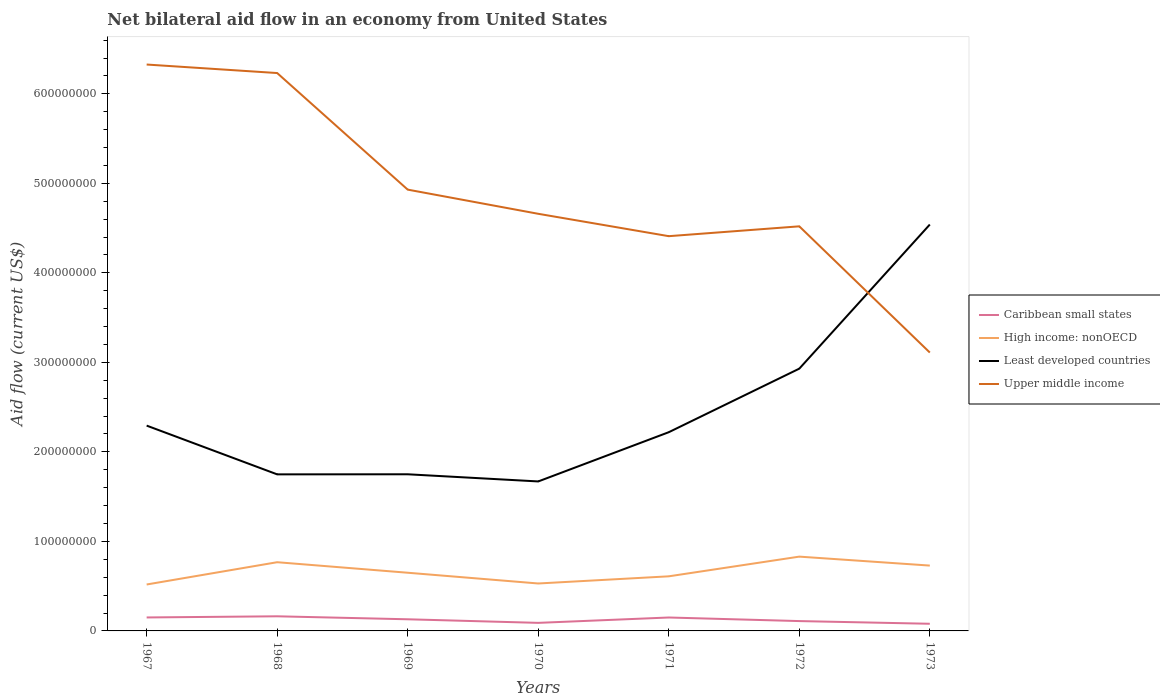Across all years, what is the maximum net bilateral aid flow in Caribbean small states?
Make the answer very short. 8.00e+06. In which year was the net bilateral aid flow in Least developed countries maximum?
Ensure brevity in your answer.  1970. What is the difference between the highest and the second highest net bilateral aid flow in High income: nonOECD?
Offer a very short reply. 3.11e+07. How many lines are there?
Ensure brevity in your answer.  4. What is the difference between two consecutive major ticks on the Y-axis?
Ensure brevity in your answer.  1.00e+08. Does the graph contain any zero values?
Provide a short and direct response. No. Does the graph contain grids?
Provide a succinct answer. No. How many legend labels are there?
Provide a succinct answer. 4. How are the legend labels stacked?
Offer a terse response. Vertical. What is the title of the graph?
Make the answer very short. Net bilateral aid flow in an economy from United States. Does "World" appear as one of the legend labels in the graph?
Offer a very short reply. No. What is the Aid flow (current US$) of Caribbean small states in 1967?
Give a very brief answer. 1.50e+07. What is the Aid flow (current US$) in High income: nonOECD in 1967?
Give a very brief answer. 5.19e+07. What is the Aid flow (current US$) in Least developed countries in 1967?
Ensure brevity in your answer.  2.29e+08. What is the Aid flow (current US$) in Upper middle income in 1967?
Provide a succinct answer. 6.33e+08. What is the Aid flow (current US$) in Caribbean small states in 1968?
Your answer should be compact. 1.63e+07. What is the Aid flow (current US$) in High income: nonOECD in 1968?
Make the answer very short. 7.68e+07. What is the Aid flow (current US$) of Least developed countries in 1968?
Give a very brief answer. 1.75e+08. What is the Aid flow (current US$) in Upper middle income in 1968?
Your answer should be compact. 6.23e+08. What is the Aid flow (current US$) in Caribbean small states in 1969?
Offer a terse response. 1.30e+07. What is the Aid flow (current US$) in High income: nonOECD in 1969?
Make the answer very short. 6.50e+07. What is the Aid flow (current US$) in Least developed countries in 1969?
Make the answer very short. 1.75e+08. What is the Aid flow (current US$) of Upper middle income in 1969?
Ensure brevity in your answer.  4.93e+08. What is the Aid flow (current US$) in Caribbean small states in 1970?
Provide a succinct answer. 9.00e+06. What is the Aid flow (current US$) in High income: nonOECD in 1970?
Your answer should be very brief. 5.30e+07. What is the Aid flow (current US$) of Least developed countries in 1970?
Your answer should be very brief. 1.67e+08. What is the Aid flow (current US$) in Upper middle income in 1970?
Your response must be concise. 4.66e+08. What is the Aid flow (current US$) in Caribbean small states in 1971?
Provide a short and direct response. 1.50e+07. What is the Aid flow (current US$) of High income: nonOECD in 1971?
Your answer should be very brief. 6.10e+07. What is the Aid flow (current US$) of Least developed countries in 1971?
Offer a terse response. 2.22e+08. What is the Aid flow (current US$) in Upper middle income in 1971?
Give a very brief answer. 4.41e+08. What is the Aid flow (current US$) in Caribbean small states in 1972?
Provide a short and direct response. 1.10e+07. What is the Aid flow (current US$) of High income: nonOECD in 1972?
Offer a terse response. 8.30e+07. What is the Aid flow (current US$) of Least developed countries in 1972?
Offer a terse response. 2.93e+08. What is the Aid flow (current US$) of Upper middle income in 1972?
Offer a terse response. 4.52e+08. What is the Aid flow (current US$) in Caribbean small states in 1973?
Offer a terse response. 8.00e+06. What is the Aid flow (current US$) in High income: nonOECD in 1973?
Offer a terse response. 7.30e+07. What is the Aid flow (current US$) in Least developed countries in 1973?
Your answer should be compact. 4.54e+08. What is the Aid flow (current US$) in Upper middle income in 1973?
Your answer should be very brief. 3.11e+08. Across all years, what is the maximum Aid flow (current US$) in Caribbean small states?
Give a very brief answer. 1.63e+07. Across all years, what is the maximum Aid flow (current US$) in High income: nonOECD?
Make the answer very short. 8.30e+07. Across all years, what is the maximum Aid flow (current US$) in Least developed countries?
Offer a very short reply. 4.54e+08. Across all years, what is the maximum Aid flow (current US$) of Upper middle income?
Offer a terse response. 6.33e+08. Across all years, what is the minimum Aid flow (current US$) in High income: nonOECD?
Your answer should be compact. 5.19e+07. Across all years, what is the minimum Aid flow (current US$) of Least developed countries?
Offer a very short reply. 1.67e+08. Across all years, what is the minimum Aid flow (current US$) of Upper middle income?
Give a very brief answer. 3.11e+08. What is the total Aid flow (current US$) in Caribbean small states in the graph?
Offer a very short reply. 8.74e+07. What is the total Aid flow (current US$) of High income: nonOECD in the graph?
Keep it short and to the point. 4.64e+08. What is the total Aid flow (current US$) in Least developed countries in the graph?
Keep it short and to the point. 1.72e+09. What is the total Aid flow (current US$) in Upper middle income in the graph?
Ensure brevity in your answer.  3.42e+09. What is the difference between the Aid flow (current US$) of Caribbean small states in 1967 and that in 1968?
Provide a succinct answer. -1.28e+06. What is the difference between the Aid flow (current US$) in High income: nonOECD in 1967 and that in 1968?
Offer a very short reply. -2.49e+07. What is the difference between the Aid flow (current US$) of Least developed countries in 1967 and that in 1968?
Your response must be concise. 5.45e+07. What is the difference between the Aid flow (current US$) in Upper middle income in 1967 and that in 1968?
Offer a terse response. 9.51e+06. What is the difference between the Aid flow (current US$) of Caribbean small states in 1967 and that in 1969?
Provide a succinct answer. 2.05e+06. What is the difference between the Aid flow (current US$) of High income: nonOECD in 1967 and that in 1969?
Make the answer very short. -1.31e+07. What is the difference between the Aid flow (current US$) of Least developed countries in 1967 and that in 1969?
Give a very brief answer. 5.44e+07. What is the difference between the Aid flow (current US$) of Upper middle income in 1967 and that in 1969?
Offer a terse response. 1.40e+08. What is the difference between the Aid flow (current US$) in Caribbean small states in 1967 and that in 1970?
Offer a terse response. 6.05e+06. What is the difference between the Aid flow (current US$) of High income: nonOECD in 1967 and that in 1970?
Keep it short and to the point. -1.13e+06. What is the difference between the Aid flow (current US$) of Least developed countries in 1967 and that in 1970?
Make the answer very short. 6.24e+07. What is the difference between the Aid flow (current US$) in Upper middle income in 1967 and that in 1970?
Keep it short and to the point. 1.67e+08. What is the difference between the Aid flow (current US$) in Caribbean small states in 1967 and that in 1971?
Offer a very short reply. 5.00e+04. What is the difference between the Aid flow (current US$) of High income: nonOECD in 1967 and that in 1971?
Offer a terse response. -9.13e+06. What is the difference between the Aid flow (current US$) of Least developed countries in 1967 and that in 1971?
Make the answer very short. 7.37e+06. What is the difference between the Aid flow (current US$) in Upper middle income in 1967 and that in 1971?
Your response must be concise. 1.92e+08. What is the difference between the Aid flow (current US$) in Caribbean small states in 1967 and that in 1972?
Ensure brevity in your answer.  4.05e+06. What is the difference between the Aid flow (current US$) in High income: nonOECD in 1967 and that in 1972?
Your answer should be very brief. -3.11e+07. What is the difference between the Aid flow (current US$) of Least developed countries in 1967 and that in 1972?
Your answer should be very brief. -6.36e+07. What is the difference between the Aid flow (current US$) in Upper middle income in 1967 and that in 1972?
Give a very brief answer. 1.81e+08. What is the difference between the Aid flow (current US$) of Caribbean small states in 1967 and that in 1973?
Make the answer very short. 7.05e+06. What is the difference between the Aid flow (current US$) in High income: nonOECD in 1967 and that in 1973?
Offer a terse response. -2.11e+07. What is the difference between the Aid flow (current US$) of Least developed countries in 1967 and that in 1973?
Offer a terse response. -2.25e+08. What is the difference between the Aid flow (current US$) of Upper middle income in 1967 and that in 1973?
Provide a succinct answer. 3.22e+08. What is the difference between the Aid flow (current US$) in Caribbean small states in 1968 and that in 1969?
Keep it short and to the point. 3.33e+06. What is the difference between the Aid flow (current US$) of High income: nonOECD in 1968 and that in 1969?
Keep it short and to the point. 1.18e+07. What is the difference between the Aid flow (current US$) of Least developed countries in 1968 and that in 1969?
Your response must be concise. -1.00e+05. What is the difference between the Aid flow (current US$) in Upper middle income in 1968 and that in 1969?
Your answer should be compact. 1.30e+08. What is the difference between the Aid flow (current US$) in Caribbean small states in 1968 and that in 1970?
Provide a succinct answer. 7.33e+06. What is the difference between the Aid flow (current US$) in High income: nonOECD in 1968 and that in 1970?
Keep it short and to the point. 2.38e+07. What is the difference between the Aid flow (current US$) of Least developed countries in 1968 and that in 1970?
Give a very brief answer. 7.90e+06. What is the difference between the Aid flow (current US$) of Upper middle income in 1968 and that in 1970?
Your answer should be very brief. 1.57e+08. What is the difference between the Aid flow (current US$) of Caribbean small states in 1968 and that in 1971?
Keep it short and to the point. 1.33e+06. What is the difference between the Aid flow (current US$) of High income: nonOECD in 1968 and that in 1971?
Your answer should be very brief. 1.58e+07. What is the difference between the Aid flow (current US$) of Least developed countries in 1968 and that in 1971?
Offer a terse response. -4.71e+07. What is the difference between the Aid flow (current US$) of Upper middle income in 1968 and that in 1971?
Ensure brevity in your answer.  1.82e+08. What is the difference between the Aid flow (current US$) of Caribbean small states in 1968 and that in 1972?
Provide a succinct answer. 5.33e+06. What is the difference between the Aid flow (current US$) of High income: nonOECD in 1968 and that in 1972?
Your answer should be very brief. -6.24e+06. What is the difference between the Aid flow (current US$) of Least developed countries in 1968 and that in 1972?
Your answer should be very brief. -1.18e+08. What is the difference between the Aid flow (current US$) in Upper middle income in 1968 and that in 1972?
Your answer should be very brief. 1.71e+08. What is the difference between the Aid flow (current US$) of Caribbean small states in 1968 and that in 1973?
Your answer should be compact. 8.33e+06. What is the difference between the Aid flow (current US$) of High income: nonOECD in 1968 and that in 1973?
Offer a terse response. 3.76e+06. What is the difference between the Aid flow (current US$) in Least developed countries in 1968 and that in 1973?
Keep it short and to the point. -2.79e+08. What is the difference between the Aid flow (current US$) of Upper middle income in 1968 and that in 1973?
Offer a terse response. 3.12e+08. What is the difference between the Aid flow (current US$) of Caribbean small states in 1969 and that in 1970?
Your answer should be compact. 4.00e+06. What is the difference between the Aid flow (current US$) in High income: nonOECD in 1969 and that in 1970?
Your response must be concise. 1.20e+07. What is the difference between the Aid flow (current US$) in Least developed countries in 1969 and that in 1970?
Offer a terse response. 8.00e+06. What is the difference between the Aid flow (current US$) of Upper middle income in 1969 and that in 1970?
Your answer should be very brief. 2.70e+07. What is the difference between the Aid flow (current US$) of Least developed countries in 1969 and that in 1971?
Ensure brevity in your answer.  -4.70e+07. What is the difference between the Aid flow (current US$) in Upper middle income in 1969 and that in 1971?
Ensure brevity in your answer.  5.20e+07. What is the difference between the Aid flow (current US$) in High income: nonOECD in 1969 and that in 1972?
Your answer should be very brief. -1.80e+07. What is the difference between the Aid flow (current US$) in Least developed countries in 1969 and that in 1972?
Make the answer very short. -1.18e+08. What is the difference between the Aid flow (current US$) in Upper middle income in 1969 and that in 1972?
Provide a short and direct response. 4.10e+07. What is the difference between the Aid flow (current US$) in High income: nonOECD in 1969 and that in 1973?
Provide a short and direct response. -8.00e+06. What is the difference between the Aid flow (current US$) of Least developed countries in 1969 and that in 1973?
Ensure brevity in your answer.  -2.79e+08. What is the difference between the Aid flow (current US$) in Upper middle income in 1969 and that in 1973?
Offer a terse response. 1.82e+08. What is the difference between the Aid flow (current US$) of Caribbean small states in 1970 and that in 1971?
Your answer should be very brief. -6.00e+06. What is the difference between the Aid flow (current US$) in High income: nonOECD in 1970 and that in 1971?
Your answer should be compact. -8.00e+06. What is the difference between the Aid flow (current US$) in Least developed countries in 1970 and that in 1971?
Your response must be concise. -5.50e+07. What is the difference between the Aid flow (current US$) of Upper middle income in 1970 and that in 1971?
Your answer should be very brief. 2.50e+07. What is the difference between the Aid flow (current US$) of Caribbean small states in 1970 and that in 1972?
Give a very brief answer. -2.00e+06. What is the difference between the Aid flow (current US$) in High income: nonOECD in 1970 and that in 1972?
Your answer should be compact. -3.00e+07. What is the difference between the Aid flow (current US$) in Least developed countries in 1970 and that in 1972?
Provide a short and direct response. -1.26e+08. What is the difference between the Aid flow (current US$) of Upper middle income in 1970 and that in 1972?
Your answer should be very brief. 1.40e+07. What is the difference between the Aid flow (current US$) in High income: nonOECD in 1970 and that in 1973?
Offer a very short reply. -2.00e+07. What is the difference between the Aid flow (current US$) of Least developed countries in 1970 and that in 1973?
Your answer should be compact. -2.87e+08. What is the difference between the Aid flow (current US$) in Upper middle income in 1970 and that in 1973?
Provide a short and direct response. 1.55e+08. What is the difference between the Aid flow (current US$) in High income: nonOECD in 1971 and that in 1972?
Keep it short and to the point. -2.20e+07. What is the difference between the Aid flow (current US$) of Least developed countries in 1971 and that in 1972?
Your response must be concise. -7.10e+07. What is the difference between the Aid flow (current US$) in Upper middle income in 1971 and that in 1972?
Your response must be concise. -1.10e+07. What is the difference between the Aid flow (current US$) in High income: nonOECD in 1971 and that in 1973?
Your response must be concise. -1.20e+07. What is the difference between the Aid flow (current US$) in Least developed countries in 1971 and that in 1973?
Give a very brief answer. -2.32e+08. What is the difference between the Aid flow (current US$) in Upper middle income in 1971 and that in 1973?
Offer a terse response. 1.30e+08. What is the difference between the Aid flow (current US$) of High income: nonOECD in 1972 and that in 1973?
Your response must be concise. 1.00e+07. What is the difference between the Aid flow (current US$) of Least developed countries in 1972 and that in 1973?
Offer a very short reply. -1.61e+08. What is the difference between the Aid flow (current US$) in Upper middle income in 1972 and that in 1973?
Provide a succinct answer. 1.41e+08. What is the difference between the Aid flow (current US$) in Caribbean small states in 1967 and the Aid flow (current US$) in High income: nonOECD in 1968?
Ensure brevity in your answer.  -6.17e+07. What is the difference between the Aid flow (current US$) in Caribbean small states in 1967 and the Aid flow (current US$) in Least developed countries in 1968?
Provide a succinct answer. -1.60e+08. What is the difference between the Aid flow (current US$) of Caribbean small states in 1967 and the Aid flow (current US$) of Upper middle income in 1968?
Provide a succinct answer. -6.08e+08. What is the difference between the Aid flow (current US$) in High income: nonOECD in 1967 and the Aid flow (current US$) in Least developed countries in 1968?
Offer a terse response. -1.23e+08. What is the difference between the Aid flow (current US$) of High income: nonOECD in 1967 and the Aid flow (current US$) of Upper middle income in 1968?
Ensure brevity in your answer.  -5.71e+08. What is the difference between the Aid flow (current US$) in Least developed countries in 1967 and the Aid flow (current US$) in Upper middle income in 1968?
Your response must be concise. -3.94e+08. What is the difference between the Aid flow (current US$) in Caribbean small states in 1967 and the Aid flow (current US$) in High income: nonOECD in 1969?
Offer a very short reply. -5.00e+07. What is the difference between the Aid flow (current US$) of Caribbean small states in 1967 and the Aid flow (current US$) of Least developed countries in 1969?
Give a very brief answer. -1.60e+08. What is the difference between the Aid flow (current US$) in Caribbean small states in 1967 and the Aid flow (current US$) in Upper middle income in 1969?
Your answer should be very brief. -4.78e+08. What is the difference between the Aid flow (current US$) of High income: nonOECD in 1967 and the Aid flow (current US$) of Least developed countries in 1969?
Offer a terse response. -1.23e+08. What is the difference between the Aid flow (current US$) of High income: nonOECD in 1967 and the Aid flow (current US$) of Upper middle income in 1969?
Offer a terse response. -4.41e+08. What is the difference between the Aid flow (current US$) of Least developed countries in 1967 and the Aid flow (current US$) of Upper middle income in 1969?
Ensure brevity in your answer.  -2.64e+08. What is the difference between the Aid flow (current US$) in Caribbean small states in 1967 and the Aid flow (current US$) in High income: nonOECD in 1970?
Provide a short and direct response. -3.80e+07. What is the difference between the Aid flow (current US$) in Caribbean small states in 1967 and the Aid flow (current US$) in Least developed countries in 1970?
Make the answer very short. -1.52e+08. What is the difference between the Aid flow (current US$) in Caribbean small states in 1967 and the Aid flow (current US$) in Upper middle income in 1970?
Your answer should be compact. -4.51e+08. What is the difference between the Aid flow (current US$) in High income: nonOECD in 1967 and the Aid flow (current US$) in Least developed countries in 1970?
Offer a terse response. -1.15e+08. What is the difference between the Aid flow (current US$) in High income: nonOECD in 1967 and the Aid flow (current US$) in Upper middle income in 1970?
Your answer should be compact. -4.14e+08. What is the difference between the Aid flow (current US$) of Least developed countries in 1967 and the Aid flow (current US$) of Upper middle income in 1970?
Keep it short and to the point. -2.37e+08. What is the difference between the Aid flow (current US$) in Caribbean small states in 1967 and the Aid flow (current US$) in High income: nonOECD in 1971?
Provide a short and direct response. -4.60e+07. What is the difference between the Aid flow (current US$) in Caribbean small states in 1967 and the Aid flow (current US$) in Least developed countries in 1971?
Provide a short and direct response. -2.07e+08. What is the difference between the Aid flow (current US$) in Caribbean small states in 1967 and the Aid flow (current US$) in Upper middle income in 1971?
Offer a very short reply. -4.26e+08. What is the difference between the Aid flow (current US$) in High income: nonOECD in 1967 and the Aid flow (current US$) in Least developed countries in 1971?
Your answer should be very brief. -1.70e+08. What is the difference between the Aid flow (current US$) of High income: nonOECD in 1967 and the Aid flow (current US$) of Upper middle income in 1971?
Provide a short and direct response. -3.89e+08. What is the difference between the Aid flow (current US$) of Least developed countries in 1967 and the Aid flow (current US$) of Upper middle income in 1971?
Your answer should be compact. -2.12e+08. What is the difference between the Aid flow (current US$) in Caribbean small states in 1967 and the Aid flow (current US$) in High income: nonOECD in 1972?
Your answer should be compact. -6.80e+07. What is the difference between the Aid flow (current US$) in Caribbean small states in 1967 and the Aid flow (current US$) in Least developed countries in 1972?
Provide a short and direct response. -2.78e+08. What is the difference between the Aid flow (current US$) in Caribbean small states in 1967 and the Aid flow (current US$) in Upper middle income in 1972?
Give a very brief answer. -4.37e+08. What is the difference between the Aid flow (current US$) of High income: nonOECD in 1967 and the Aid flow (current US$) of Least developed countries in 1972?
Your response must be concise. -2.41e+08. What is the difference between the Aid flow (current US$) in High income: nonOECD in 1967 and the Aid flow (current US$) in Upper middle income in 1972?
Your response must be concise. -4.00e+08. What is the difference between the Aid flow (current US$) in Least developed countries in 1967 and the Aid flow (current US$) in Upper middle income in 1972?
Your answer should be compact. -2.23e+08. What is the difference between the Aid flow (current US$) of Caribbean small states in 1967 and the Aid flow (current US$) of High income: nonOECD in 1973?
Give a very brief answer. -5.80e+07. What is the difference between the Aid flow (current US$) of Caribbean small states in 1967 and the Aid flow (current US$) of Least developed countries in 1973?
Offer a very short reply. -4.39e+08. What is the difference between the Aid flow (current US$) of Caribbean small states in 1967 and the Aid flow (current US$) of Upper middle income in 1973?
Make the answer very short. -2.96e+08. What is the difference between the Aid flow (current US$) of High income: nonOECD in 1967 and the Aid flow (current US$) of Least developed countries in 1973?
Provide a short and direct response. -4.02e+08. What is the difference between the Aid flow (current US$) of High income: nonOECD in 1967 and the Aid flow (current US$) of Upper middle income in 1973?
Offer a terse response. -2.59e+08. What is the difference between the Aid flow (current US$) in Least developed countries in 1967 and the Aid flow (current US$) in Upper middle income in 1973?
Give a very brief answer. -8.16e+07. What is the difference between the Aid flow (current US$) of Caribbean small states in 1968 and the Aid flow (current US$) of High income: nonOECD in 1969?
Keep it short and to the point. -4.87e+07. What is the difference between the Aid flow (current US$) of Caribbean small states in 1968 and the Aid flow (current US$) of Least developed countries in 1969?
Offer a very short reply. -1.59e+08. What is the difference between the Aid flow (current US$) in Caribbean small states in 1968 and the Aid flow (current US$) in Upper middle income in 1969?
Ensure brevity in your answer.  -4.77e+08. What is the difference between the Aid flow (current US$) in High income: nonOECD in 1968 and the Aid flow (current US$) in Least developed countries in 1969?
Keep it short and to the point. -9.82e+07. What is the difference between the Aid flow (current US$) of High income: nonOECD in 1968 and the Aid flow (current US$) of Upper middle income in 1969?
Provide a succinct answer. -4.16e+08. What is the difference between the Aid flow (current US$) in Least developed countries in 1968 and the Aid flow (current US$) in Upper middle income in 1969?
Offer a very short reply. -3.18e+08. What is the difference between the Aid flow (current US$) in Caribbean small states in 1968 and the Aid flow (current US$) in High income: nonOECD in 1970?
Your answer should be compact. -3.67e+07. What is the difference between the Aid flow (current US$) of Caribbean small states in 1968 and the Aid flow (current US$) of Least developed countries in 1970?
Make the answer very short. -1.51e+08. What is the difference between the Aid flow (current US$) in Caribbean small states in 1968 and the Aid flow (current US$) in Upper middle income in 1970?
Give a very brief answer. -4.50e+08. What is the difference between the Aid flow (current US$) of High income: nonOECD in 1968 and the Aid flow (current US$) of Least developed countries in 1970?
Provide a short and direct response. -9.02e+07. What is the difference between the Aid flow (current US$) in High income: nonOECD in 1968 and the Aid flow (current US$) in Upper middle income in 1970?
Provide a succinct answer. -3.89e+08. What is the difference between the Aid flow (current US$) of Least developed countries in 1968 and the Aid flow (current US$) of Upper middle income in 1970?
Keep it short and to the point. -2.91e+08. What is the difference between the Aid flow (current US$) in Caribbean small states in 1968 and the Aid flow (current US$) in High income: nonOECD in 1971?
Make the answer very short. -4.47e+07. What is the difference between the Aid flow (current US$) of Caribbean small states in 1968 and the Aid flow (current US$) of Least developed countries in 1971?
Ensure brevity in your answer.  -2.06e+08. What is the difference between the Aid flow (current US$) in Caribbean small states in 1968 and the Aid flow (current US$) in Upper middle income in 1971?
Your answer should be compact. -4.25e+08. What is the difference between the Aid flow (current US$) in High income: nonOECD in 1968 and the Aid flow (current US$) in Least developed countries in 1971?
Your answer should be compact. -1.45e+08. What is the difference between the Aid flow (current US$) of High income: nonOECD in 1968 and the Aid flow (current US$) of Upper middle income in 1971?
Make the answer very short. -3.64e+08. What is the difference between the Aid flow (current US$) in Least developed countries in 1968 and the Aid flow (current US$) in Upper middle income in 1971?
Provide a succinct answer. -2.66e+08. What is the difference between the Aid flow (current US$) in Caribbean small states in 1968 and the Aid flow (current US$) in High income: nonOECD in 1972?
Provide a succinct answer. -6.67e+07. What is the difference between the Aid flow (current US$) in Caribbean small states in 1968 and the Aid flow (current US$) in Least developed countries in 1972?
Your answer should be compact. -2.77e+08. What is the difference between the Aid flow (current US$) of Caribbean small states in 1968 and the Aid flow (current US$) of Upper middle income in 1972?
Provide a short and direct response. -4.36e+08. What is the difference between the Aid flow (current US$) in High income: nonOECD in 1968 and the Aid flow (current US$) in Least developed countries in 1972?
Your answer should be very brief. -2.16e+08. What is the difference between the Aid flow (current US$) in High income: nonOECD in 1968 and the Aid flow (current US$) in Upper middle income in 1972?
Offer a very short reply. -3.75e+08. What is the difference between the Aid flow (current US$) of Least developed countries in 1968 and the Aid flow (current US$) of Upper middle income in 1972?
Make the answer very short. -2.77e+08. What is the difference between the Aid flow (current US$) of Caribbean small states in 1968 and the Aid flow (current US$) of High income: nonOECD in 1973?
Provide a succinct answer. -5.67e+07. What is the difference between the Aid flow (current US$) of Caribbean small states in 1968 and the Aid flow (current US$) of Least developed countries in 1973?
Give a very brief answer. -4.38e+08. What is the difference between the Aid flow (current US$) of Caribbean small states in 1968 and the Aid flow (current US$) of Upper middle income in 1973?
Provide a succinct answer. -2.95e+08. What is the difference between the Aid flow (current US$) of High income: nonOECD in 1968 and the Aid flow (current US$) of Least developed countries in 1973?
Offer a very short reply. -3.77e+08. What is the difference between the Aid flow (current US$) of High income: nonOECD in 1968 and the Aid flow (current US$) of Upper middle income in 1973?
Keep it short and to the point. -2.34e+08. What is the difference between the Aid flow (current US$) in Least developed countries in 1968 and the Aid flow (current US$) in Upper middle income in 1973?
Your answer should be compact. -1.36e+08. What is the difference between the Aid flow (current US$) in Caribbean small states in 1969 and the Aid flow (current US$) in High income: nonOECD in 1970?
Make the answer very short. -4.00e+07. What is the difference between the Aid flow (current US$) of Caribbean small states in 1969 and the Aid flow (current US$) of Least developed countries in 1970?
Your answer should be very brief. -1.54e+08. What is the difference between the Aid flow (current US$) of Caribbean small states in 1969 and the Aid flow (current US$) of Upper middle income in 1970?
Make the answer very short. -4.53e+08. What is the difference between the Aid flow (current US$) of High income: nonOECD in 1969 and the Aid flow (current US$) of Least developed countries in 1970?
Keep it short and to the point. -1.02e+08. What is the difference between the Aid flow (current US$) of High income: nonOECD in 1969 and the Aid flow (current US$) of Upper middle income in 1970?
Your answer should be compact. -4.01e+08. What is the difference between the Aid flow (current US$) of Least developed countries in 1969 and the Aid flow (current US$) of Upper middle income in 1970?
Offer a very short reply. -2.91e+08. What is the difference between the Aid flow (current US$) of Caribbean small states in 1969 and the Aid flow (current US$) of High income: nonOECD in 1971?
Make the answer very short. -4.80e+07. What is the difference between the Aid flow (current US$) in Caribbean small states in 1969 and the Aid flow (current US$) in Least developed countries in 1971?
Provide a short and direct response. -2.09e+08. What is the difference between the Aid flow (current US$) of Caribbean small states in 1969 and the Aid flow (current US$) of Upper middle income in 1971?
Provide a succinct answer. -4.28e+08. What is the difference between the Aid flow (current US$) of High income: nonOECD in 1969 and the Aid flow (current US$) of Least developed countries in 1971?
Ensure brevity in your answer.  -1.57e+08. What is the difference between the Aid flow (current US$) in High income: nonOECD in 1969 and the Aid flow (current US$) in Upper middle income in 1971?
Offer a terse response. -3.76e+08. What is the difference between the Aid flow (current US$) of Least developed countries in 1969 and the Aid flow (current US$) of Upper middle income in 1971?
Your answer should be very brief. -2.66e+08. What is the difference between the Aid flow (current US$) of Caribbean small states in 1969 and the Aid flow (current US$) of High income: nonOECD in 1972?
Ensure brevity in your answer.  -7.00e+07. What is the difference between the Aid flow (current US$) in Caribbean small states in 1969 and the Aid flow (current US$) in Least developed countries in 1972?
Keep it short and to the point. -2.80e+08. What is the difference between the Aid flow (current US$) in Caribbean small states in 1969 and the Aid flow (current US$) in Upper middle income in 1972?
Offer a very short reply. -4.39e+08. What is the difference between the Aid flow (current US$) in High income: nonOECD in 1969 and the Aid flow (current US$) in Least developed countries in 1972?
Give a very brief answer. -2.28e+08. What is the difference between the Aid flow (current US$) in High income: nonOECD in 1969 and the Aid flow (current US$) in Upper middle income in 1972?
Your response must be concise. -3.87e+08. What is the difference between the Aid flow (current US$) in Least developed countries in 1969 and the Aid flow (current US$) in Upper middle income in 1972?
Ensure brevity in your answer.  -2.77e+08. What is the difference between the Aid flow (current US$) of Caribbean small states in 1969 and the Aid flow (current US$) of High income: nonOECD in 1973?
Your response must be concise. -6.00e+07. What is the difference between the Aid flow (current US$) in Caribbean small states in 1969 and the Aid flow (current US$) in Least developed countries in 1973?
Provide a succinct answer. -4.41e+08. What is the difference between the Aid flow (current US$) in Caribbean small states in 1969 and the Aid flow (current US$) in Upper middle income in 1973?
Make the answer very short. -2.98e+08. What is the difference between the Aid flow (current US$) of High income: nonOECD in 1969 and the Aid flow (current US$) of Least developed countries in 1973?
Provide a succinct answer. -3.89e+08. What is the difference between the Aid flow (current US$) in High income: nonOECD in 1969 and the Aid flow (current US$) in Upper middle income in 1973?
Give a very brief answer. -2.46e+08. What is the difference between the Aid flow (current US$) of Least developed countries in 1969 and the Aid flow (current US$) of Upper middle income in 1973?
Your answer should be very brief. -1.36e+08. What is the difference between the Aid flow (current US$) in Caribbean small states in 1970 and the Aid flow (current US$) in High income: nonOECD in 1971?
Your answer should be very brief. -5.20e+07. What is the difference between the Aid flow (current US$) of Caribbean small states in 1970 and the Aid flow (current US$) of Least developed countries in 1971?
Keep it short and to the point. -2.13e+08. What is the difference between the Aid flow (current US$) of Caribbean small states in 1970 and the Aid flow (current US$) of Upper middle income in 1971?
Your response must be concise. -4.32e+08. What is the difference between the Aid flow (current US$) of High income: nonOECD in 1970 and the Aid flow (current US$) of Least developed countries in 1971?
Ensure brevity in your answer.  -1.69e+08. What is the difference between the Aid flow (current US$) of High income: nonOECD in 1970 and the Aid flow (current US$) of Upper middle income in 1971?
Your answer should be compact. -3.88e+08. What is the difference between the Aid flow (current US$) of Least developed countries in 1970 and the Aid flow (current US$) of Upper middle income in 1971?
Your response must be concise. -2.74e+08. What is the difference between the Aid flow (current US$) of Caribbean small states in 1970 and the Aid flow (current US$) of High income: nonOECD in 1972?
Your response must be concise. -7.40e+07. What is the difference between the Aid flow (current US$) of Caribbean small states in 1970 and the Aid flow (current US$) of Least developed countries in 1972?
Your answer should be very brief. -2.84e+08. What is the difference between the Aid flow (current US$) in Caribbean small states in 1970 and the Aid flow (current US$) in Upper middle income in 1972?
Provide a short and direct response. -4.43e+08. What is the difference between the Aid flow (current US$) of High income: nonOECD in 1970 and the Aid flow (current US$) of Least developed countries in 1972?
Your answer should be very brief. -2.40e+08. What is the difference between the Aid flow (current US$) of High income: nonOECD in 1970 and the Aid flow (current US$) of Upper middle income in 1972?
Give a very brief answer. -3.99e+08. What is the difference between the Aid flow (current US$) in Least developed countries in 1970 and the Aid flow (current US$) in Upper middle income in 1972?
Keep it short and to the point. -2.85e+08. What is the difference between the Aid flow (current US$) of Caribbean small states in 1970 and the Aid flow (current US$) of High income: nonOECD in 1973?
Your answer should be compact. -6.40e+07. What is the difference between the Aid flow (current US$) in Caribbean small states in 1970 and the Aid flow (current US$) in Least developed countries in 1973?
Provide a succinct answer. -4.45e+08. What is the difference between the Aid flow (current US$) in Caribbean small states in 1970 and the Aid flow (current US$) in Upper middle income in 1973?
Give a very brief answer. -3.02e+08. What is the difference between the Aid flow (current US$) in High income: nonOECD in 1970 and the Aid flow (current US$) in Least developed countries in 1973?
Your response must be concise. -4.01e+08. What is the difference between the Aid flow (current US$) of High income: nonOECD in 1970 and the Aid flow (current US$) of Upper middle income in 1973?
Give a very brief answer. -2.58e+08. What is the difference between the Aid flow (current US$) of Least developed countries in 1970 and the Aid flow (current US$) of Upper middle income in 1973?
Ensure brevity in your answer.  -1.44e+08. What is the difference between the Aid flow (current US$) of Caribbean small states in 1971 and the Aid flow (current US$) of High income: nonOECD in 1972?
Make the answer very short. -6.80e+07. What is the difference between the Aid flow (current US$) of Caribbean small states in 1971 and the Aid flow (current US$) of Least developed countries in 1972?
Offer a very short reply. -2.78e+08. What is the difference between the Aid flow (current US$) in Caribbean small states in 1971 and the Aid flow (current US$) in Upper middle income in 1972?
Your response must be concise. -4.37e+08. What is the difference between the Aid flow (current US$) of High income: nonOECD in 1971 and the Aid flow (current US$) of Least developed countries in 1972?
Offer a terse response. -2.32e+08. What is the difference between the Aid flow (current US$) of High income: nonOECD in 1971 and the Aid flow (current US$) of Upper middle income in 1972?
Give a very brief answer. -3.91e+08. What is the difference between the Aid flow (current US$) in Least developed countries in 1971 and the Aid flow (current US$) in Upper middle income in 1972?
Make the answer very short. -2.30e+08. What is the difference between the Aid flow (current US$) in Caribbean small states in 1971 and the Aid flow (current US$) in High income: nonOECD in 1973?
Provide a short and direct response. -5.80e+07. What is the difference between the Aid flow (current US$) in Caribbean small states in 1971 and the Aid flow (current US$) in Least developed countries in 1973?
Ensure brevity in your answer.  -4.39e+08. What is the difference between the Aid flow (current US$) in Caribbean small states in 1971 and the Aid flow (current US$) in Upper middle income in 1973?
Your answer should be very brief. -2.96e+08. What is the difference between the Aid flow (current US$) in High income: nonOECD in 1971 and the Aid flow (current US$) in Least developed countries in 1973?
Ensure brevity in your answer.  -3.93e+08. What is the difference between the Aid flow (current US$) in High income: nonOECD in 1971 and the Aid flow (current US$) in Upper middle income in 1973?
Your answer should be compact. -2.50e+08. What is the difference between the Aid flow (current US$) of Least developed countries in 1971 and the Aid flow (current US$) of Upper middle income in 1973?
Ensure brevity in your answer.  -8.90e+07. What is the difference between the Aid flow (current US$) in Caribbean small states in 1972 and the Aid flow (current US$) in High income: nonOECD in 1973?
Provide a short and direct response. -6.20e+07. What is the difference between the Aid flow (current US$) in Caribbean small states in 1972 and the Aid flow (current US$) in Least developed countries in 1973?
Provide a short and direct response. -4.43e+08. What is the difference between the Aid flow (current US$) of Caribbean small states in 1972 and the Aid flow (current US$) of Upper middle income in 1973?
Your answer should be compact. -3.00e+08. What is the difference between the Aid flow (current US$) in High income: nonOECD in 1972 and the Aid flow (current US$) in Least developed countries in 1973?
Provide a short and direct response. -3.71e+08. What is the difference between the Aid flow (current US$) of High income: nonOECD in 1972 and the Aid flow (current US$) of Upper middle income in 1973?
Provide a succinct answer. -2.28e+08. What is the difference between the Aid flow (current US$) of Least developed countries in 1972 and the Aid flow (current US$) of Upper middle income in 1973?
Keep it short and to the point. -1.80e+07. What is the average Aid flow (current US$) of Caribbean small states per year?
Give a very brief answer. 1.25e+07. What is the average Aid flow (current US$) in High income: nonOECD per year?
Keep it short and to the point. 6.62e+07. What is the average Aid flow (current US$) of Least developed countries per year?
Your response must be concise. 2.45e+08. What is the average Aid flow (current US$) of Upper middle income per year?
Offer a terse response. 4.88e+08. In the year 1967, what is the difference between the Aid flow (current US$) in Caribbean small states and Aid flow (current US$) in High income: nonOECD?
Provide a succinct answer. -3.68e+07. In the year 1967, what is the difference between the Aid flow (current US$) of Caribbean small states and Aid flow (current US$) of Least developed countries?
Offer a very short reply. -2.14e+08. In the year 1967, what is the difference between the Aid flow (current US$) in Caribbean small states and Aid flow (current US$) in Upper middle income?
Your answer should be very brief. -6.18e+08. In the year 1967, what is the difference between the Aid flow (current US$) of High income: nonOECD and Aid flow (current US$) of Least developed countries?
Make the answer very short. -1.78e+08. In the year 1967, what is the difference between the Aid flow (current US$) in High income: nonOECD and Aid flow (current US$) in Upper middle income?
Make the answer very short. -5.81e+08. In the year 1967, what is the difference between the Aid flow (current US$) of Least developed countries and Aid flow (current US$) of Upper middle income?
Keep it short and to the point. -4.03e+08. In the year 1968, what is the difference between the Aid flow (current US$) in Caribbean small states and Aid flow (current US$) in High income: nonOECD?
Ensure brevity in your answer.  -6.04e+07. In the year 1968, what is the difference between the Aid flow (current US$) in Caribbean small states and Aid flow (current US$) in Least developed countries?
Offer a very short reply. -1.59e+08. In the year 1968, what is the difference between the Aid flow (current US$) in Caribbean small states and Aid flow (current US$) in Upper middle income?
Give a very brief answer. -6.07e+08. In the year 1968, what is the difference between the Aid flow (current US$) of High income: nonOECD and Aid flow (current US$) of Least developed countries?
Offer a very short reply. -9.81e+07. In the year 1968, what is the difference between the Aid flow (current US$) in High income: nonOECD and Aid flow (current US$) in Upper middle income?
Offer a very short reply. -5.46e+08. In the year 1968, what is the difference between the Aid flow (current US$) in Least developed countries and Aid flow (current US$) in Upper middle income?
Give a very brief answer. -4.48e+08. In the year 1969, what is the difference between the Aid flow (current US$) of Caribbean small states and Aid flow (current US$) of High income: nonOECD?
Make the answer very short. -5.20e+07. In the year 1969, what is the difference between the Aid flow (current US$) of Caribbean small states and Aid flow (current US$) of Least developed countries?
Your response must be concise. -1.62e+08. In the year 1969, what is the difference between the Aid flow (current US$) in Caribbean small states and Aid flow (current US$) in Upper middle income?
Offer a very short reply. -4.80e+08. In the year 1969, what is the difference between the Aid flow (current US$) in High income: nonOECD and Aid flow (current US$) in Least developed countries?
Provide a short and direct response. -1.10e+08. In the year 1969, what is the difference between the Aid flow (current US$) in High income: nonOECD and Aid flow (current US$) in Upper middle income?
Your response must be concise. -4.28e+08. In the year 1969, what is the difference between the Aid flow (current US$) of Least developed countries and Aid flow (current US$) of Upper middle income?
Make the answer very short. -3.18e+08. In the year 1970, what is the difference between the Aid flow (current US$) of Caribbean small states and Aid flow (current US$) of High income: nonOECD?
Give a very brief answer. -4.40e+07. In the year 1970, what is the difference between the Aid flow (current US$) of Caribbean small states and Aid flow (current US$) of Least developed countries?
Offer a terse response. -1.58e+08. In the year 1970, what is the difference between the Aid flow (current US$) in Caribbean small states and Aid flow (current US$) in Upper middle income?
Provide a short and direct response. -4.57e+08. In the year 1970, what is the difference between the Aid flow (current US$) in High income: nonOECD and Aid flow (current US$) in Least developed countries?
Provide a short and direct response. -1.14e+08. In the year 1970, what is the difference between the Aid flow (current US$) of High income: nonOECD and Aid flow (current US$) of Upper middle income?
Offer a terse response. -4.13e+08. In the year 1970, what is the difference between the Aid flow (current US$) in Least developed countries and Aid flow (current US$) in Upper middle income?
Your answer should be very brief. -2.99e+08. In the year 1971, what is the difference between the Aid flow (current US$) in Caribbean small states and Aid flow (current US$) in High income: nonOECD?
Provide a short and direct response. -4.60e+07. In the year 1971, what is the difference between the Aid flow (current US$) in Caribbean small states and Aid flow (current US$) in Least developed countries?
Provide a short and direct response. -2.07e+08. In the year 1971, what is the difference between the Aid flow (current US$) of Caribbean small states and Aid flow (current US$) of Upper middle income?
Provide a short and direct response. -4.26e+08. In the year 1971, what is the difference between the Aid flow (current US$) in High income: nonOECD and Aid flow (current US$) in Least developed countries?
Keep it short and to the point. -1.61e+08. In the year 1971, what is the difference between the Aid flow (current US$) of High income: nonOECD and Aid flow (current US$) of Upper middle income?
Provide a succinct answer. -3.80e+08. In the year 1971, what is the difference between the Aid flow (current US$) in Least developed countries and Aid flow (current US$) in Upper middle income?
Your answer should be very brief. -2.19e+08. In the year 1972, what is the difference between the Aid flow (current US$) of Caribbean small states and Aid flow (current US$) of High income: nonOECD?
Your answer should be very brief. -7.20e+07. In the year 1972, what is the difference between the Aid flow (current US$) of Caribbean small states and Aid flow (current US$) of Least developed countries?
Your response must be concise. -2.82e+08. In the year 1972, what is the difference between the Aid flow (current US$) of Caribbean small states and Aid flow (current US$) of Upper middle income?
Ensure brevity in your answer.  -4.41e+08. In the year 1972, what is the difference between the Aid flow (current US$) of High income: nonOECD and Aid flow (current US$) of Least developed countries?
Provide a short and direct response. -2.10e+08. In the year 1972, what is the difference between the Aid flow (current US$) in High income: nonOECD and Aid flow (current US$) in Upper middle income?
Offer a very short reply. -3.69e+08. In the year 1972, what is the difference between the Aid flow (current US$) in Least developed countries and Aid flow (current US$) in Upper middle income?
Your answer should be very brief. -1.59e+08. In the year 1973, what is the difference between the Aid flow (current US$) in Caribbean small states and Aid flow (current US$) in High income: nonOECD?
Your answer should be compact. -6.50e+07. In the year 1973, what is the difference between the Aid flow (current US$) of Caribbean small states and Aid flow (current US$) of Least developed countries?
Your answer should be compact. -4.46e+08. In the year 1973, what is the difference between the Aid flow (current US$) in Caribbean small states and Aid flow (current US$) in Upper middle income?
Give a very brief answer. -3.03e+08. In the year 1973, what is the difference between the Aid flow (current US$) of High income: nonOECD and Aid flow (current US$) of Least developed countries?
Ensure brevity in your answer.  -3.81e+08. In the year 1973, what is the difference between the Aid flow (current US$) in High income: nonOECD and Aid flow (current US$) in Upper middle income?
Keep it short and to the point. -2.38e+08. In the year 1973, what is the difference between the Aid flow (current US$) in Least developed countries and Aid flow (current US$) in Upper middle income?
Your response must be concise. 1.43e+08. What is the ratio of the Aid flow (current US$) in Caribbean small states in 1967 to that in 1968?
Offer a very short reply. 0.92. What is the ratio of the Aid flow (current US$) of High income: nonOECD in 1967 to that in 1968?
Make the answer very short. 0.68. What is the ratio of the Aid flow (current US$) of Least developed countries in 1967 to that in 1968?
Provide a succinct answer. 1.31. What is the ratio of the Aid flow (current US$) of Upper middle income in 1967 to that in 1968?
Make the answer very short. 1.02. What is the ratio of the Aid flow (current US$) in Caribbean small states in 1967 to that in 1969?
Offer a terse response. 1.16. What is the ratio of the Aid flow (current US$) of High income: nonOECD in 1967 to that in 1969?
Your response must be concise. 0.8. What is the ratio of the Aid flow (current US$) in Least developed countries in 1967 to that in 1969?
Your response must be concise. 1.31. What is the ratio of the Aid flow (current US$) in Upper middle income in 1967 to that in 1969?
Keep it short and to the point. 1.28. What is the ratio of the Aid flow (current US$) in Caribbean small states in 1967 to that in 1970?
Your answer should be compact. 1.67. What is the ratio of the Aid flow (current US$) in High income: nonOECD in 1967 to that in 1970?
Make the answer very short. 0.98. What is the ratio of the Aid flow (current US$) in Least developed countries in 1967 to that in 1970?
Offer a terse response. 1.37. What is the ratio of the Aid flow (current US$) of Upper middle income in 1967 to that in 1970?
Offer a terse response. 1.36. What is the ratio of the Aid flow (current US$) of High income: nonOECD in 1967 to that in 1971?
Keep it short and to the point. 0.85. What is the ratio of the Aid flow (current US$) in Least developed countries in 1967 to that in 1971?
Offer a very short reply. 1.03. What is the ratio of the Aid flow (current US$) in Upper middle income in 1967 to that in 1971?
Your answer should be compact. 1.43. What is the ratio of the Aid flow (current US$) in Caribbean small states in 1967 to that in 1972?
Provide a succinct answer. 1.37. What is the ratio of the Aid flow (current US$) in High income: nonOECD in 1967 to that in 1972?
Ensure brevity in your answer.  0.62. What is the ratio of the Aid flow (current US$) of Least developed countries in 1967 to that in 1972?
Offer a very short reply. 0.78. What is the ratio of the Aid flow (current US$) of Upper middle income in 1967 to that in 1972?
Offer a very short reply. 1.4. What is the ratio of the Aid flow (current US$) of Caribbean small states in 1967 to that in 1973?
Your response must be concise. 1.88. What is the ratio of the Aid flow (current US$) in High income: nonOECD in 1967 to that in 1973?
Provide a short and direct response. 0.71. What is the ratio of the Aid flow (current US$) in Least developed countries in 1967 to that in 1973?
Your answer should be compact. 0.51. What is the ratio of the Aid flow (current US$) in Upper middle income in 1967 to that in 1973?
Your answer should be compact. 2.03. What is the ratio of the Aid flow (current US$) of Caribbean small states in 1968 to that in 1969?
Your answer should be very brief. 1.26. What is the ratio of the Aid flow (current US$) in High income: nonOECD in 1968 to that in 1969?
Offer a terse response. 1.18. What is the ratio of the Aid flow (current US$) of Least developed countries in 1968 to that in 1969?
Provide a succinct answer. 1. What is the ratio of the Aid flow (current US$) in Upper middle income in 1968 to that in 1969?
Keep it short and to the point. 1.26. What is the ratio of the Aid flow (current US$) of Caribbean small states in 1968 to that in 1970?
Make the answer very short. 1.81. What is the ratio of the Aid flow (current US$) in High income: nonOECD in 1968 to that in 1970?
Provide a short and direct response. 1.45. What is the ratio of the Aid flow (current US$) of Least developed countries in 1968 to that in 1970?
Keep it short and to the point. 1.05. What is the ratio of the Aid flow (current US$) of Upper middle income in 1968 to that in 1970?
Offer a terse response. 1.34. What is the ratio of the Aid flow (current US$) in Caribbean small states in 1968 to that in 1971?
Your answer should be very brief. 1.09. What is the ratio of the Aid flow (current US$) of High income: nonOECD in 1968 to that in 1971?
Keep it short and to the point. 1.26. What is the ratio of the Aid flow (current US$) in Least developed countries in 1968 to that in 1971?
Give a very brief answer. 0.79. What is the ratio of the Aid flow (current US$) of Upper middle income in 1968 to that in 1971?
Keep it short and to the point. 1.41. What is the ratio of the Aid flow (current US$) in Caribbean small states in 1968 to that in 1972?
Ensure brevity in your answer.  1.48. What is the ratio of the Aid flow (current US$) of High income: nonOECD in 1968 to that in 1972?
Your answer should be compact. 0.92. What is the ratio of the Aid flow (current US$) in Least developed countries in 1968 to that in 1972?
Keep it short and to the point. 0.6. What is the ratio of the Aid flow (current US$) in Upper middle income in 1968 to that in 1972?
Make the answer very short. 1.38. What is the ratio of the Aid flow (current US$) in Caribbean small states in 1968 to that in 1973?
Your answer should be very brief. 2.04. What is the ratio of the Aid flow (current US$) of High income: nonOECD in 1968 to that in 1973?
Your answer should be very brief. 1.05. What is the ratio of the Aid flow (current US$) in Least developed countries in 1968 to that in 1973?
Make the answer very short. 0.39. What is the ratio of the Aid flow (current US$) of Upper middle income in 1968 to that in 1973?
Offer a very short reply. 2. What is the ratio of the Aid flow (current US$) of Caribbean small states in 1969 to that in 1970?
Provide a short and direct response. 1.44. What is the ratio of the Aid flow (current US$) of High income: nonOECD in 1969 to that in 1970?
Provide a short and direct response. 1.23. What is the ratio of the Aid flow (current US$) in Least developed countries in 1969 to that in 1970?
Keep it short and to the point. 1.05. What is the ratio of the Aid flow (current US$) of Upper middle income in 1969 to that in 1970?
Your answer should be very brief. 1.06. What is the ratio of the Aid flow (current US$) of Caribbean small states in 1969 to that in 1971?
Ensure brevity in your answer.  0.87. What is the ratio of the Aid flow (current US$) in High income: nonOECD in 1969 to that in 1971?
Offer a very short reply. 1.07. What is the ratio of the Aid flow (current US$) of Least developed countries in 1969 to that in 1971?
Your response must be concise. 0.79. What is the ratio of the Aid flow (current US$) of Upper middle income in 1969 to that in 1971?
Make the answer very short. 1.12. What is the ratio of the Aid flow (current US$) of Caribbean small states in 1969 to that in 1972?
Provide a succinct answer. 1.18. What is the ratio of the Aid flow (current US$) in High income: nonOECD in 1969 to that in 1972?
Your answer should be very brief. 0.78. What is the ratio of the Aid flow (current US$) in Least developed countries in 1969 to that in 1972?
Your answer should be very brief. 0.6. What is the ratio of the Aid flow (current US$) of Upper middle income in 1969 to that in 1972?
Provide a short and direct response. 1.09. What is the ratio of the Aid flow (current US$) of Caribbean small states in 1969 to that in 1973?
Your response must be concise. 1.62. What is the ratio of the Aid flow (current US$) of High income: nonOECD in 1969 to that in 1973?
Your answer should be very brief. 0.89. What is the ratio of the Aid flow (current US$) of Least developed countries in 1969 to that in 1973?
Give a very brief answer. 0.39. What is the ratio of the Aid flow (current US$) in Upper middle income in 1969 to that in 1973?
Ensure brevity in your answer.  1.59. What is the ratio of the Aid flow (current US$) in High income: nonOECD in 1970 to that in 1971?
Provide a succinct answer. 0.87. What is the ratio of the Aid flow (current US$) in Least developed countries in 1970 to that in 1971?
Give a very brief answer. 0.75. What is the ratio of the Aid flow (current US$) of Upper middle income in 1970 to that in 1971?
Your response must be concise. 1.06. What is the ratio of the Aid flow (current US$) in Caribbean small states in 1970 to that in 1972?
Provide a succinct answer. 0.82. What is the ratio of the Aid flow (current US$) in High income: nonOECD in 1970 to that in 1972?
Keep it short and to the point. 0.64. What is the ratio of the Aid flow (current US$) of Least developed countries in 1970 to that in 1972?
Provide a succinct answer. 0.57. What is the ratio of the Aid flow (current US$) of Upper middle income in 1970 to that in 1972?
Keep it short and to the point. 1.03. What is the ratio of the Aid flow (current US$) of Caribbean small states in 1970 to that in 1973?
Make the answer very short. 1.12. What is the ratio of the Aid flow (current US$) of High income: nonOECD in 1970 to that in 1973?
Ensure brevity in your answer.  0.73. What is the ratio of the Aid flow (current US$) of Least developed countries in 1970 to that in 1973?
Make the answer very short. 0.37. What is the ratio of the Aid flow (current US$) in Upper middle income in 1970 to that in 1973?
Your response must be concise. 1.5. What is the ratio of the Aid flow (current US$) in Caribbean small states in 1971 to that in 1972?
Provide a succinct answer. 1.36. What is the ratio of the Aid flow (current US$) of High income: nonOECD in 1971 to that in 1972?
Ensure brevity in your answer.  0.73. What is the ratio of the Aid flow (current US$) in Least developed countries in 1971 to that in 1972?
Keep it short and to the point. 0.76. What is the ratio of the Aid flow (current US$) of Upper middle income in 1971 to that in 1972?
Keep it short and to the point. 0.98. What is the ratio of the Aid flow (current US$) of Caribbean small states in 1971 to that in 1973?
Offer a very short reply. 1.88. What is the ratio of the Aid flow (current US$) in High income: nonOECD in 1971 to that in 1973?
Offer a terse response. 0.84. What is the ratio of the Aid flow (current US$) of Least developed countries in 1971 to that in 1973?
Your answer should be very brief. 0.49. What is the ratio of the Aid flow (current US$) in Upper middle income in 1971 to that in 1973?
Your answer should be very brief. 1.42. What is the ratio of the Aid flow (current US$) of Caribbean small states in 1972 to that in 1973?
Offer a terse response. 1.38. What is the ratio of the Aid flow (current US$) of High income: nonOECD in 1972 to that in 1973?
Your answer should be compact. 1.14. What is the ratio of the Aid flow (current US$) in Least developed countries in 1972 to that in 1973?
Keep it short and to the point. 0.65. What is the ratio of the Aid flow (current US$) in Upper middle income in 1972 to that in 1973?
Give a very brief answer. 1.45. What is the difference between the highest and the second highest Aid flow (current US$) in Caribbean small states?
Make the answer very short. 1.28e+06. What is the difference between the highest and the second highest Aid flow (current US$) of High income: nonOECD?
Offer a terse response. 6.24e+06. What is the difference between the highest and the second highest Aid flow (current US$) in Least developed countries?
Offer a very short reply. 1.61e+08. What is the difference between the highest and the second highest Aid flow (current US$) of Upper middle income?
Ensure brevity in your answer.  9.51e+06. What is the difference between the highest and the lowest Aid flow (current US$) of Caribbean small states?
Give a very brief answer. 8.33e+06. What is the difference between the highest and the lowest Aid flow (current US$) in High income: nonOECD?
Keep it short and to the point. 3.11e+07. What is the difference between the highest and the lowest Aid flow (current US$) in Least developed countries?
Ensure brevity in your answer.  2.87e+08. What is the difference between the highest and the lowest Aid flow (current US$) of Upper middle income?
Provide a short and direct response. 3.22e+08. 